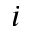<formula> <loc_0><loc_0><loc_500><loc_500>i</formula> 